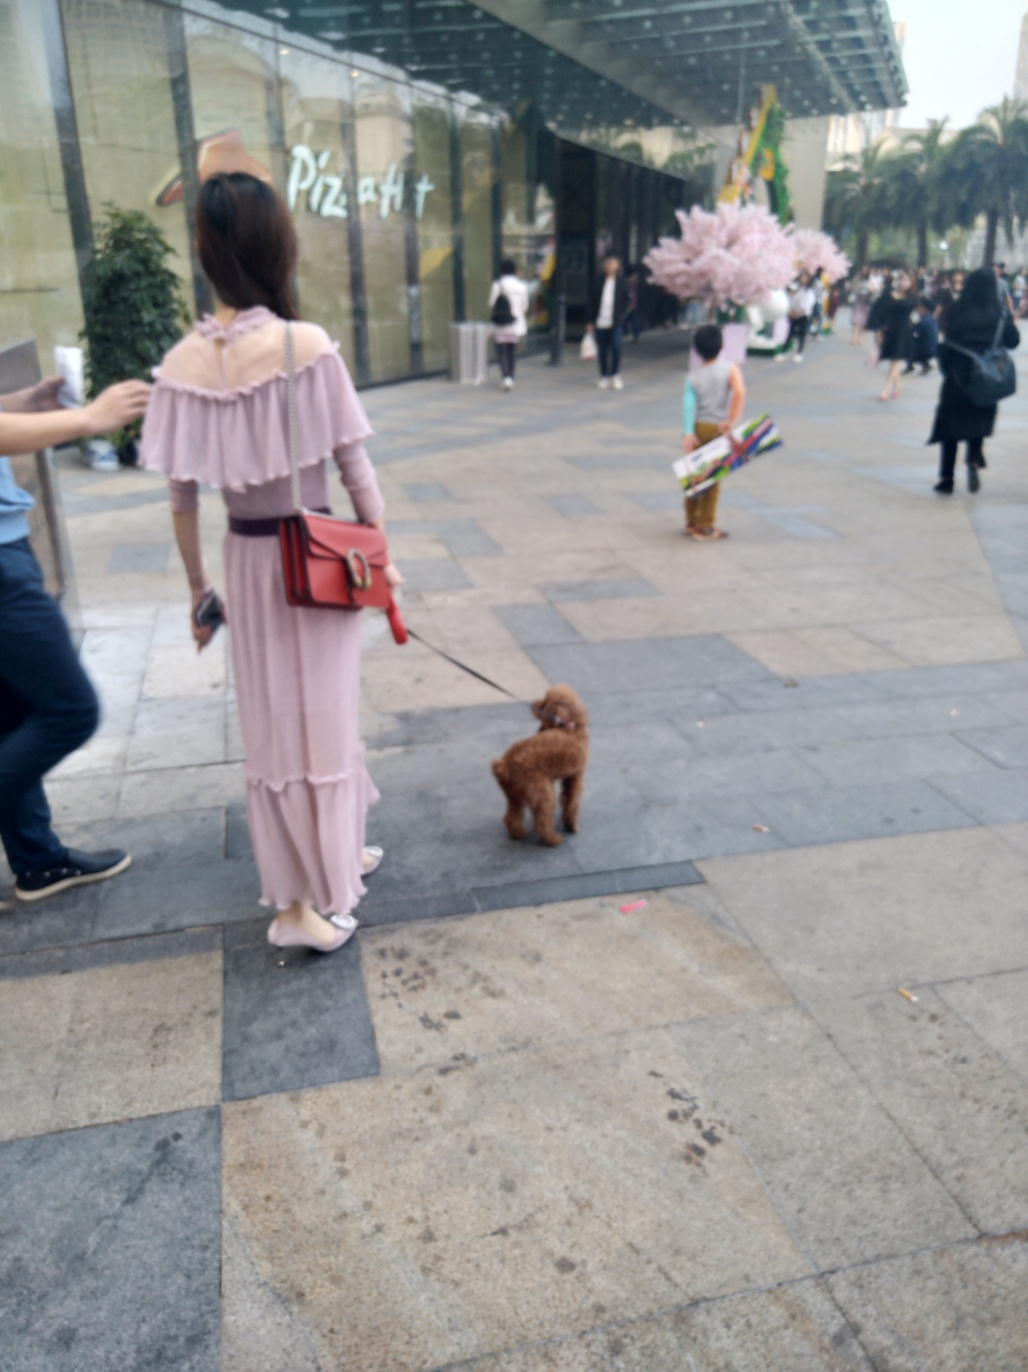Is there any indication of the weather or time of day in the image? The weather appears to be mild and comfortable, as evidenced by the attire of the people: light, casual clothing and no heavy coats, suggesting a pleasant temperature. The natural light without harsh shadows indicates either early morning or late afternoon timing. 